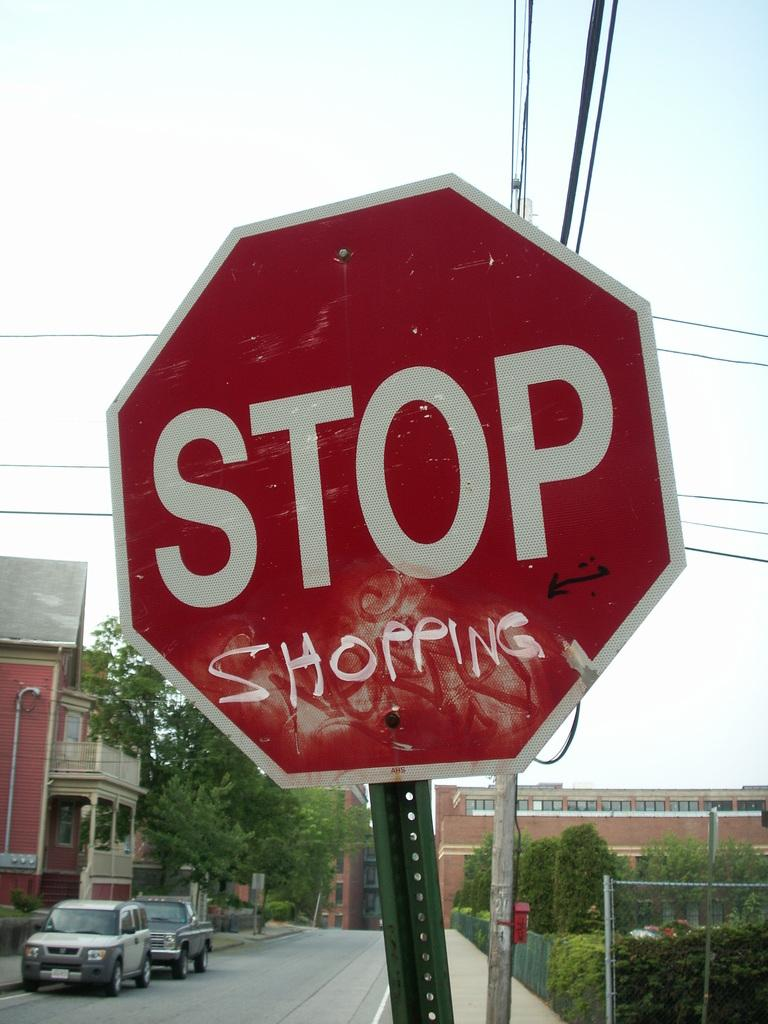<image>
Summarize the visual content of the image. Someone has graffitied the word shopping on this road sign. 